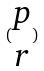<formula> <loc_0><loc_0><loc_500><loc_500>( \begin{matrix} p \\ r \end{matrix} )</formula> 